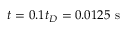Convert formula to latex. <formula><loc_0><loc_0><loc_500><loc_500>t = 0 . 1 t _ { D } = 0 . 0 1 2 5 s</formula> 